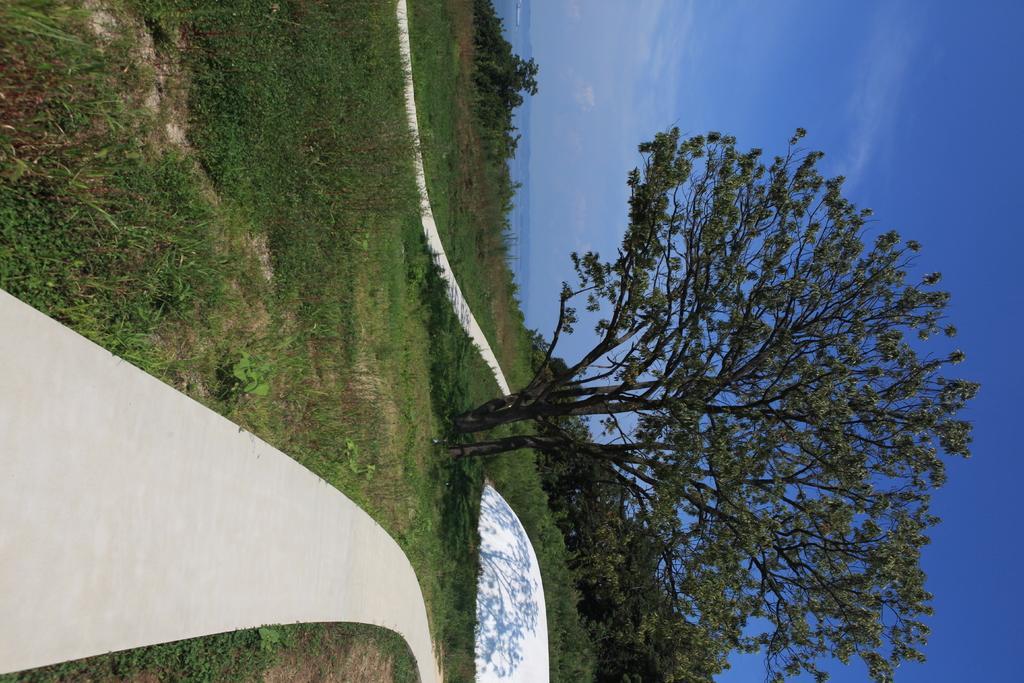Could you give a brief overview of what you see in this image? In this image we can see some trees and at the background of the image there is clear sky. 